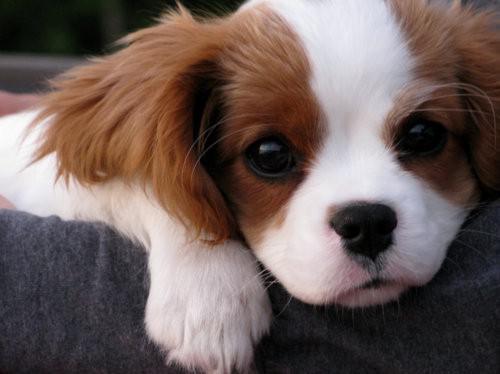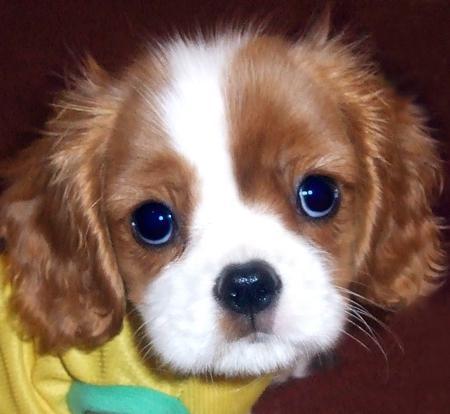The first image is the image on the left, the second image is the image on the right. Examine the images to the left and right. Is the description "One image shows a spaniel puppy inside a soft-sided pet bed, with its head upright instead of draped over the edge." accurate? Answer yes or no. No. The first image is the image on the left, the second image is the image on the right. Assess this claim about the two images: "The dog in the image on the right is lying down.". Correct or not? Answer yes or no. No. 